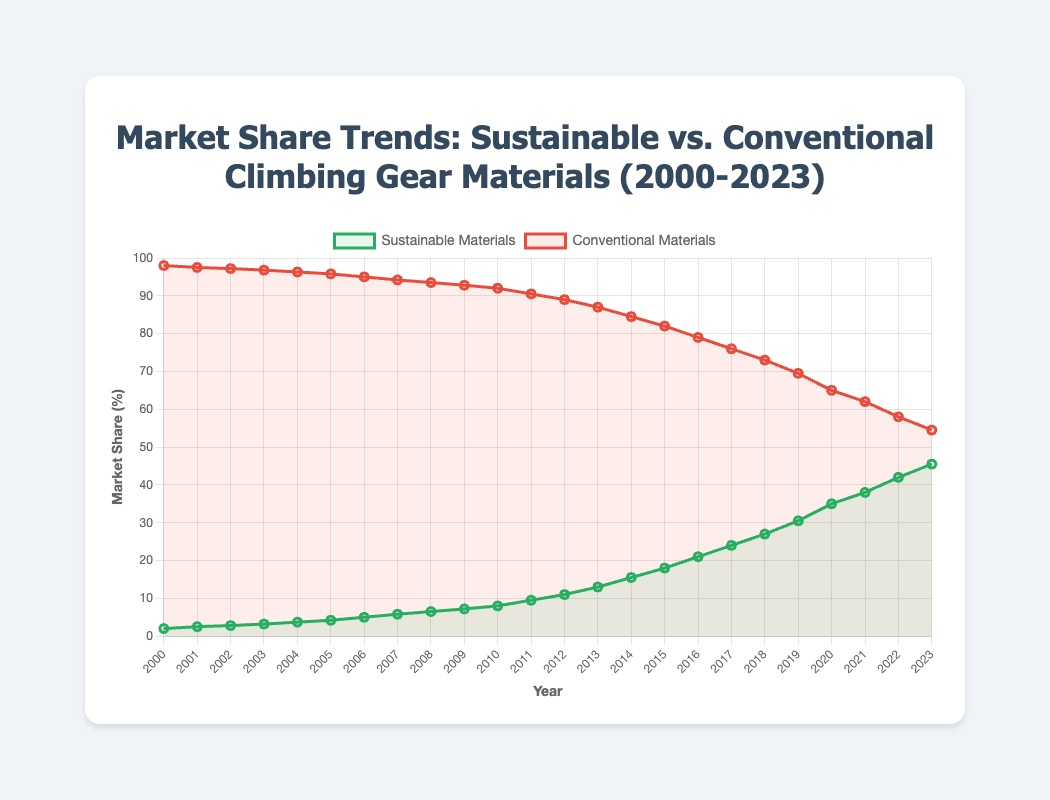What is the overall trend for the market share of sustainable materials from 2000 to 2023? The line representing sustainable materials shows an increasing trend from 2000 to 2023. Starting from 2.0% in 2000, it rises steadily each year, reaching 45.5% in 2023.
Answer: Increasing By how much did the market share of conventional materials decrease from 2000 to 2023? In 2000, the market share for conventional materials was 98.0%. By 2023, it decreased to 54.5%. The decrease is 98.0% - 54.5% = 43.5%.
Answer: 43.5% In which year did the market share of sustainable materials first exceed 10%? By looking at the data trend, the market share of sustainable materials first exceeds 10% in 2012.
Answer: 2012 Compare the market share growth rates for sustainable materials between 2000-2010 and 2010-2020. From 2000 to 2010, the market share increased from 2.0% to 8.0%, a growth of 6.0%. From 2010 to 2020, it increased from 8.0% to 35.0%, a growth of 27.0%. Hence, the growth rate is much higher between 2010 and 2020.
Answer: Higher between 2010-2020 What is the difference in market share between sustainable and conventional materials in 2018? In 2018, the market share for sustainable materials was 27.0%, and for conventional materials, it was 73.0%. The difference is 73.0% - 27.0% = 46.0%.
Answer: 46.0% Which type of material had a higher market share in 2007, and by how much? In 2007, sustainable materials had a market share of 5.8%, while conventional materials had 94.2%. Conventional materials had a higher share by 94.2% - 5.8% = 88.4%.
Answer: Conventional, 88.4% What visual trend do you notice for conventional materials from 2015 to 2023? The line representing conventional materials shows a consistent downward trend from 2015 to 2023, decreasing from 82.0% to 54.5%.
Answer: Downward trend If the market share trends continue, predict the year in which sustainable materials might surpass conventional materials. Sustainable materials are consistently gaining market share while conventional materials are losing it. By observing these trends, and assuming they continue at similar rates, sustainable materials might surpass conventional materials between 2025 and 2027.
Answer: 2025-2027 